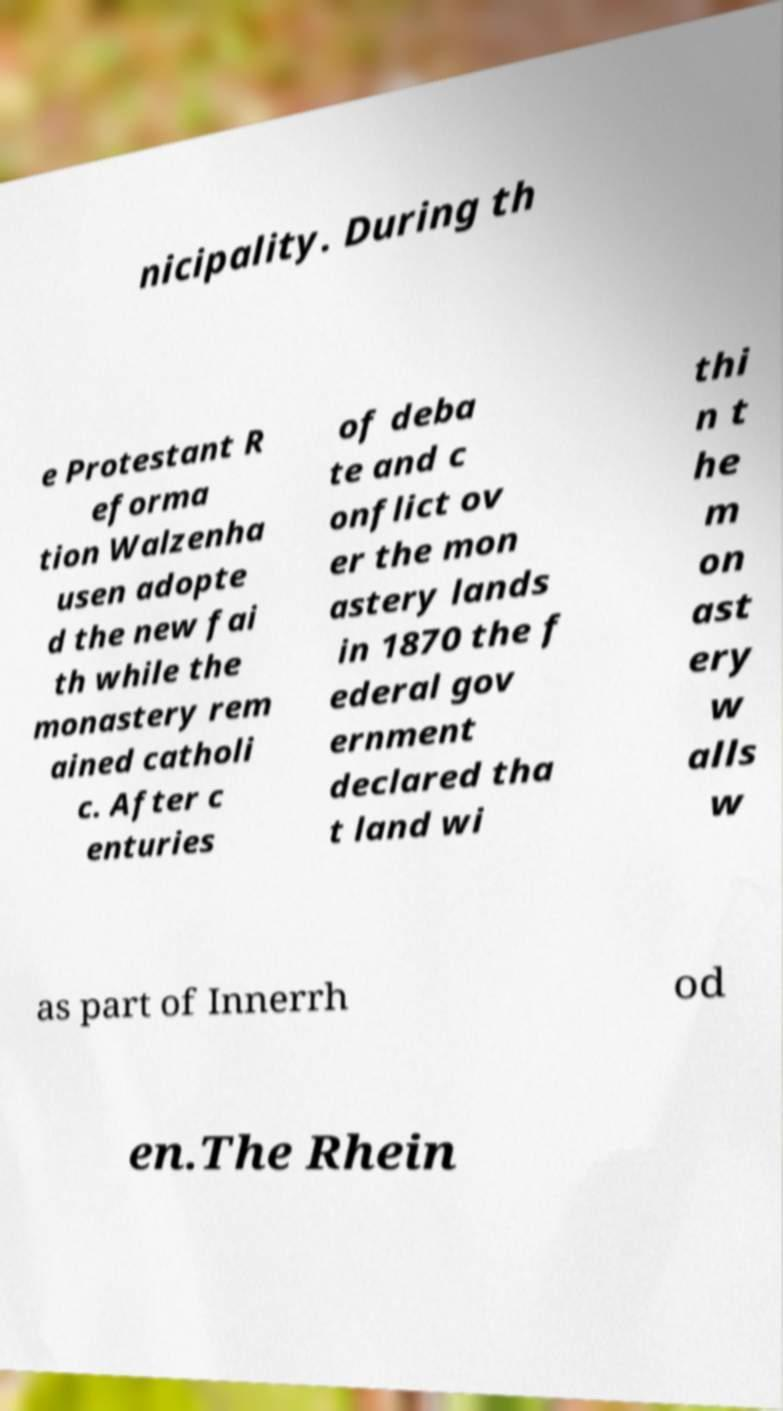Can you accurately transcribe the text from the provided image for me? nicipality. During th e Protestant R eforma tion Walzenha usen adopte d the new fai th while the monastery rem ained catholi c. After c enturies of deba te and c onflict ov er the mon astery lands in 1870 the f ederal gov ernment declared tha t land wi thi n t he m on ast ery w alls w as part of Innerrh od en.The Rhein 